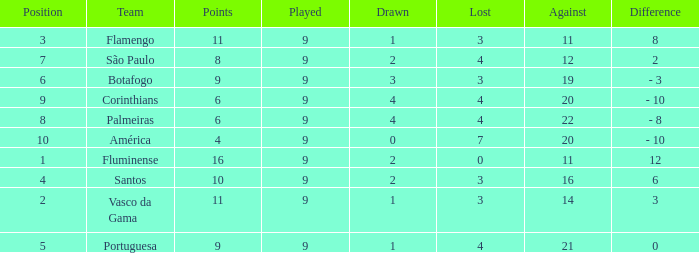Which Position has a Played larger than 9? None. 